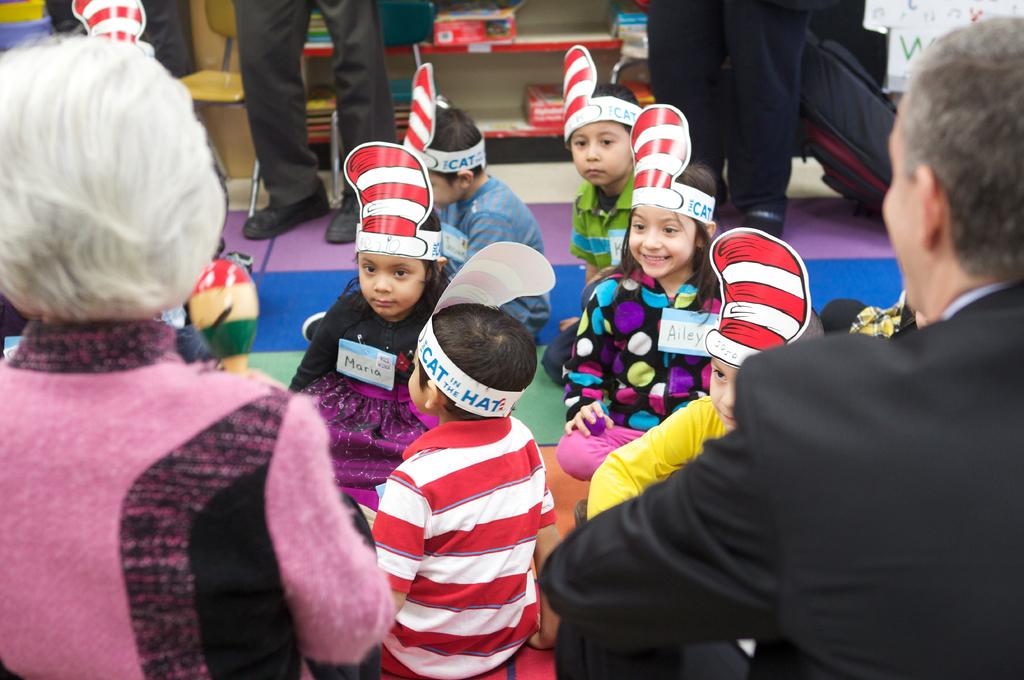Who or what can be seen in the image? There are people in the image. What are some of the people wearing on their heads? Some of the people are wearing hats with text on them. What other objects are visible in the image? There are boxes and books on racks in the image. Is there any furniture present in the image? Yes, there is a chair in the image. What type of apparatus can be seen in the image? There is no apparatus present in the image. How many birds are visible in the image? There are no birds visible in the image. 